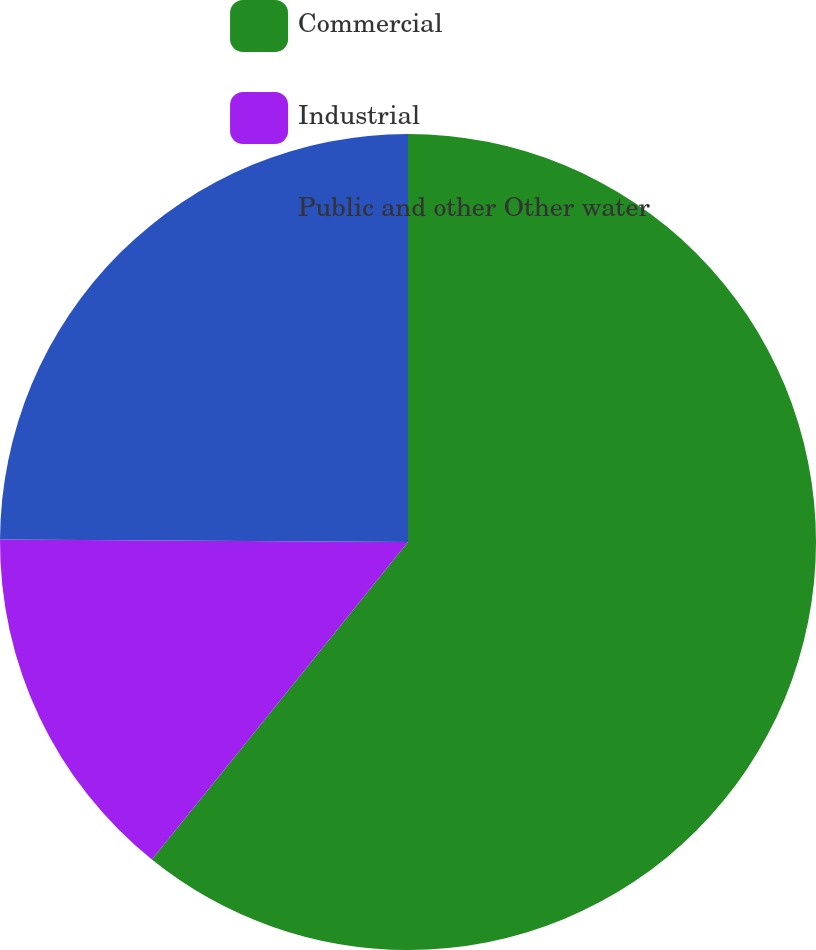Convert chart. <chart><loc_0><loc_0><loc_500><loc_500><pie_chart><fcel>Commercial<fcel>Industrial<fcel>Public and other Other water<nl><fcel>60.8%<fcel>14.3%<fcel>24.9%<nl></chart> 